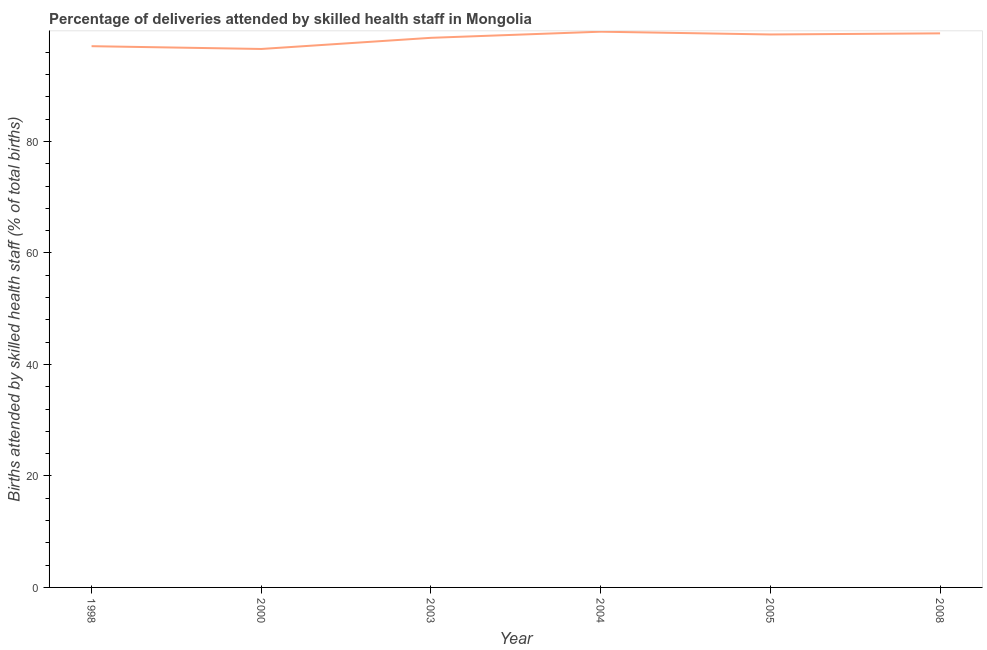What is the number of births attended by skilled health staff in 2003?
Offer a very short reply. 98.6. Across all years, what is the maximum number of births attended by skilled health staff?
Provide a short and direct response. 99.7. Across all years, what is the minimum number of births attended by skilled health staff?
Keep it short and to the point. 96.6. In which year was the number of births attended by skilled health staff maximum?
Provide a succinct answer. 2004. In which year was the number of births attended by skilled health staff minimum?
Your response must be concise. 2000. What is the sum of the number of births attended by skilled health staff?
Your answer should be compact. 590.6. What is the difference between the number of births attended by skilled health staff in 2003 and 2005?
Provide a short and direct response. -0.6. What is the average number of births attended by skilled health staff per year?
Make the answer very short. 98.43. What is the median number of births attended by skilled health staff?
Your response must be concise. 98.9. In how many years, is the number of births attended by skilled health staff greater than 12 %?
Your response must be concise. 6. Do a majority of the years between 1998 and 2000 (inclusive) have number of births attended by skilled health staff greater than 16 %?
Ensure brevity in your answer.  Yes. What is the ratio of the number of births attended by skilled health staff in 1998 to that in 2008?
Ensure brevity in your answer.  0.98. Is the number of births attended by skilled health staff in 2005 less than that in 2008?
Your answer should be compact. Yes. What is the difference between the highest and the second highest number of births attended by skilled health staff?
Offer a very short reply. 0.3. Is the sum of the number of births attended by skilled health staff in 2000 and 2005 greater than the maximum number of births attended by skilled health staff across all years?
Keep it short and to the point. Yes. What is the difference between the highest and the lowest number of births attended by skilled health staff?
Provide a succinct answer. 3.1. Does the number of births attended by skilled health staff monotonically increase over the years?
Provide a succinct answer. No. How many years are there in the graph?
Provide a succinct answer. 6. What is the difference between two consecutive major ticks on the Y-axis?
Your answer should be compact. 20. Does the graph contain grids?
Offer a terse response. No. What is the title of the graph?
Your response must be concise. Percentage of deliveries attended by skilled health staff in Mongolia. What is the label or title of the Y-axis?
Keep it short and to the point. Births attended by skilled health staff (% of total births). What is the Births attended by skilled health staff (% of total births) of 1998?
Your response must be concise. 97.1. What is the Births attended by skilled health staff (% of total births) of 2000?
Offer a terse response. 96.6. What is the Births attended by skilled health staff (% of total births) in 2003?
Offer a terse response. 98.6. What is the Births attended by skilled health staff (% of total births) in 2004?
Your response must be concise. 99.7. What is the Births attended by skilled health staff (% of total births) in 2005?
Make the answer very short. 99.2. What is the Births attended by skilled health staff (% of total births) in 2008?
Your response must be concise. 99.4. What is the difference between the Births attended by skilled health staff (% of total births) in 1998 and 2003?
Provide a succinct answer. -1.5. What is the difference between the Births attended by skilled health staff (% of total births) in 1998 and 2004?
Your answer should be compact. -2.6. What is the difference between the Births attended by skilled health staff (% of total births) in 1998 and 2005?
Offer a very short reply. -2.1. What is the difference between the Births attended by skilled health staff (% of total births) in 1998 and 2008?
Provide a succinct answer. -2.3. What is the difference between the Births attended by skilled health staff (% of total births) in 2000 and 2005?
Provide a short and direct response. -2.6. What is the difference between the Births attended by skilled health staff (% of total births) in 2003 and 2004?
Your answer should be compact. -1.1. What is the difference between the Births attended by skilled health staff (% of total births) in 2003 and 2005?
Offer a very short reply. -0.6. What is the difference between the Births attended by skilled health staff (% of total births) in 2004 and 2008?
Make the answer very short. 0.3. What is the difference between the Births attended by skilled health staff (% of total births) in 2005 and 2008?
Your answer should be very brief. -0.2. What is the ratio of the Births attended by skilled health staff (% of total births) in 1998 to that in 2008?
Offer a very short reply. 0.98. What is the ratio of the Births attended by skilled health staff (% of total births) in 2000 to that in 2004?
Your answer should be compact. 0.97. What is the ratio of the Births attended by skilled health staff (% of total births) in 2000 to that in 2008?
Keep it short and to the point. 0.97. What is the ratio of the Births attended by skilled health staff (% of total births) in 2003 to that in 2004?
Your response must be concise. 0.99. What is the ratio of the Births attended by skilled health staff (% of total births) in 2003 to that in 2008?
Your answer should be compact. 0.99. What is the ratio of the Births attended by skilled health staff (% of total births) in 2005 to that in 2008?
Give a very brief answer. 1. 